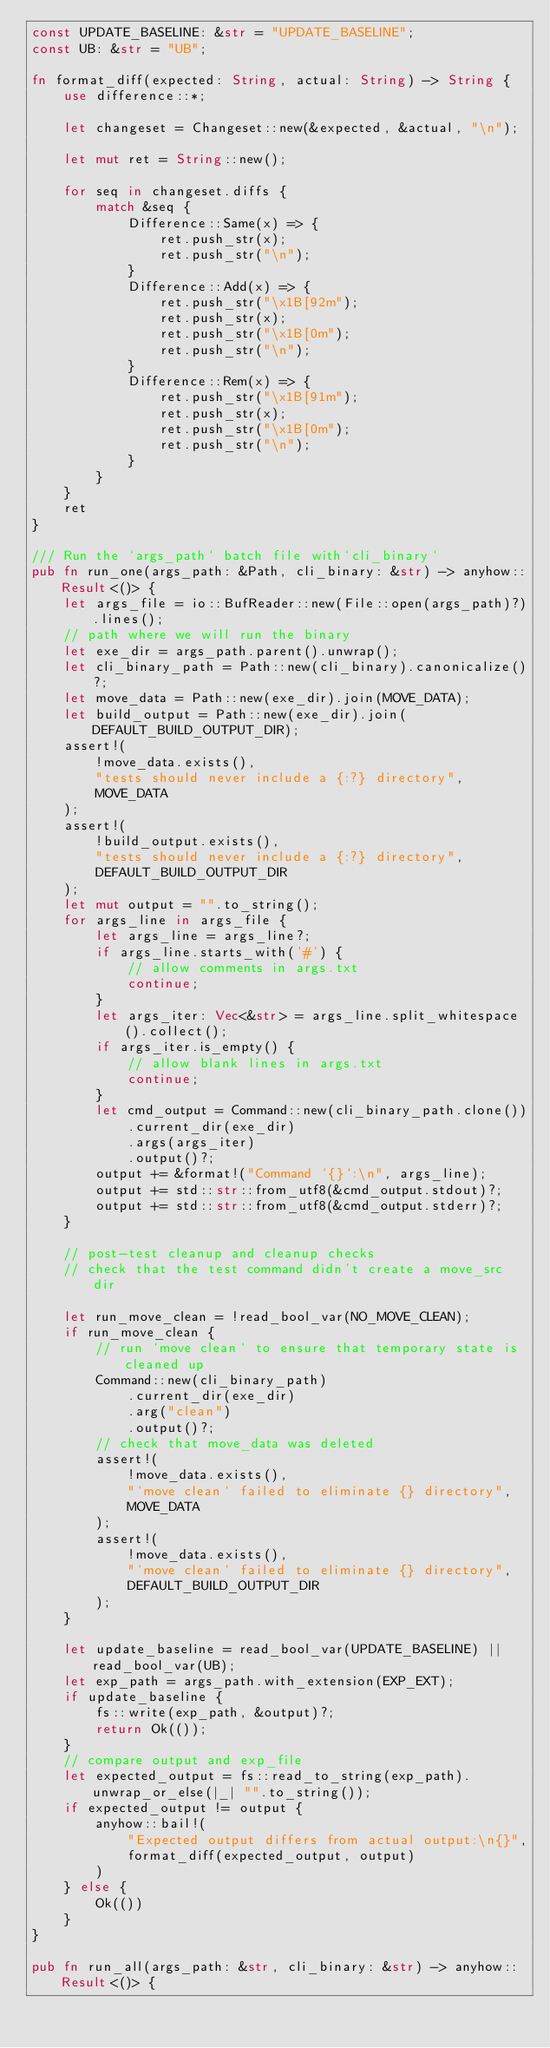Convert code to text. <code><loc_0><loc_0><loc_500><loc_500><_Rust_>const UPDATE_BASELINE: &str = "UPDATE_BASELINE";
const UB: &str = "UB";

fn format_diff(expected: String, actual: String) -> String {
    use difference::*;

    let changeset = Changeset::new(&expected, &actual, "\n");

    let mut ret = String::new();

    for seq in changeset.diffs {
        match &seq {
            Difference::Same(x) => {
                ret.push_str(x);
                ret.push_str("\n");
            }
            Difference::Add(x) => {
                ret.push_str("\x1B[92m");
                ret.push_str(x);
                ret.push_str("\x1B[0m");
                ret.push_str("\n");
            }
            Difference::Rem(x) => {
                ret.push_str("\x1B[91m");
                ret.push_str(x);
                ret.push_str("\x1B[0m");
                ret.push_str("\n");
            }
        }
    }
    ret
}

/// Run the `args_path` batch file with`cli_binary`
pub fn run_one(args_path: &Path, cli_binary: &str) -> anyhow::Result<()> {
    let args_file = io::BufReader::new(File::open(args_path)?).lines();
    // path where we will run the binary
    let exe_dir = args_path.parent().unwrap();
    let cli_binary_path = Path::new(cli_binary).canonicalize()?;
    let move_data = Path::new(exe_dir).join(MOVE_DATA);
    let build_output = Path::new(exe_dir).join(DEFAULT_BUILD_OUTPUT_DIR);
    assert!(
        !move_data.exists(),
        "tests should never include a {:?} directory",
        MOVE_DATA
    );
    assert!(
        !build_output.exists(),
        "tests should never include a {:?} directory",
        DEFAULT_BUILD_OUTPUT_DIR
    );
    let mut output = "".to_string();
    for args_line in args_file {
        let args_line = args_line?;
        if args_line.starts_with('#') {
            // allow comments in args.txt
            continue;
        }
        let args_iter: Vec<&str> = args_line.split_whitespace().collect();
        if args_iter.is_empty() {
            // allow blank lines in args.txt
            continue;
        }
        let cmd_output = Command::new(cli_binary_path.clone())
            .current_dir(exe_dir)
            .args(args_iter)
            .output()?;
        output += &format!("Command `{}`:\n", args_line);
        output += std::str::from_utf8(&cmd_output.stdout)?;
        output += std::str::from_utf8(&cmd_output.stderr)?;
    }

    // post-test cleanup and cleanup checks
    // check that the test command didn't create a move_src dir

    let run_move_clean = !read_bool_var(NO_MOVE_CLEAN);
    if run_move_clean {
        // run `move clean` to ensure that temporary state is cleaned up
        Command::new(cli_binary_path)
            .current_dir(exe_dir)
            .arg("clean")
            .output()?;
        // check that move_data was deleted
        assert!(
            !move_data.exists(),
            "`move clean` failed to eliminate {} directory",
            MOVE_DATA
        );
        assert!(
            !move_data.exists(),
            "`move clean` failed to eliminate {} directory",
            DEFAULT_BUILD_OUTPUT_DIR
        );
    }

    let update_baseline = read_bool_var(UPDATE_BASELINE) || read_bool_var(UB);
    let exp_path = args_path.with_extension(EXP_EXT);
    if update_baseline {
        fs::write(exp_path, &output)?;
        return Ok(());
    }
    // compare output and exp_file
    let expected_output = fs::read_to_string(exp_path).unwrap_or_else(|_| "".to_string());
    if expected_output != output {
        anyhow::bail!(
            "Expected output differs from actual output:\n{}",
            format_diff(expected_output, output)
        )
    } else {
        Ok(())
    }
}

pub fn run_all(args_path: &str, cli_binary: &str) -> anyhow::Result<()> {</code> 